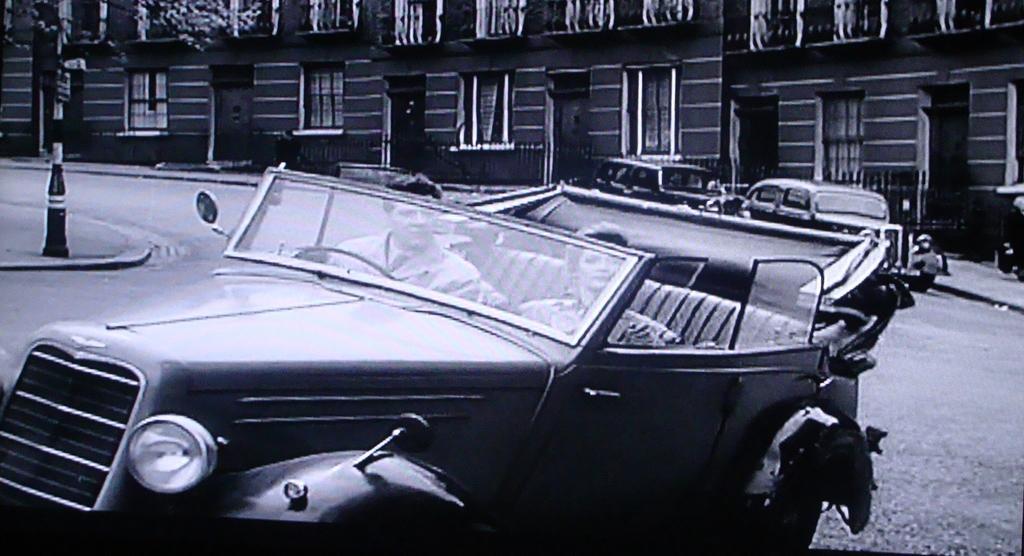How would you summarize this image in a sentence or two? In this picture there is a black and white photograph of the men and women sitting in the classic car and looking into the camera. Behind there is a building with glass windows. 